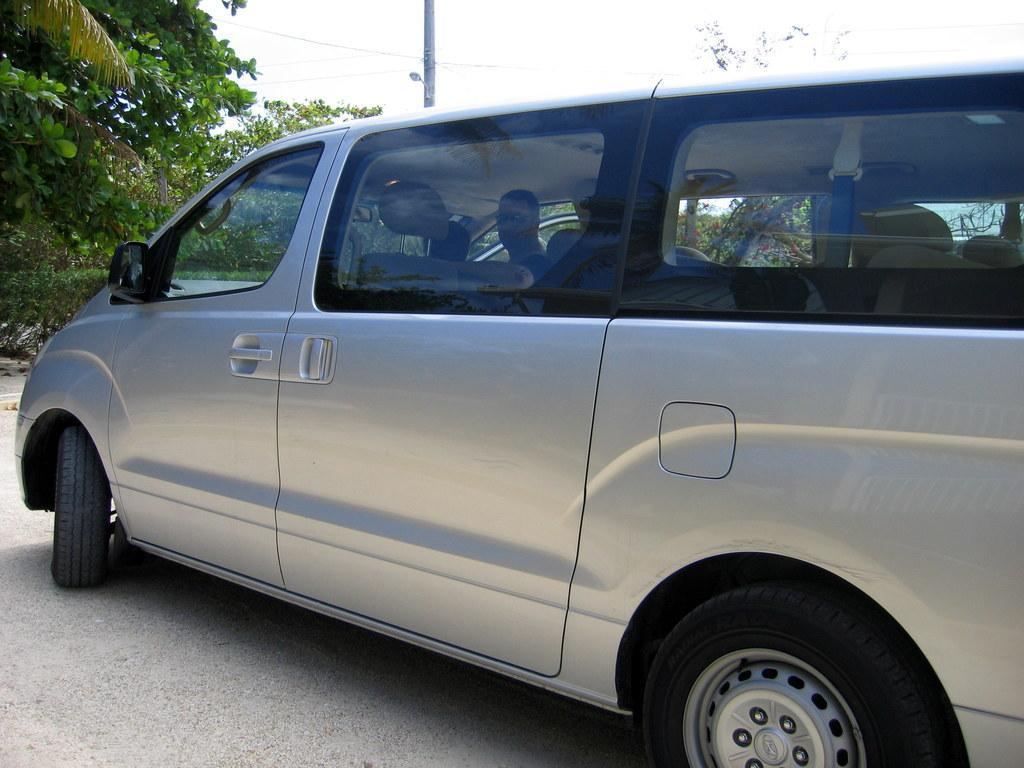Could you give a brief overview of what you see in this image? In this image I can see a vehicle and a person is sitting inside the vehicle and watching the cam. On the left side of the image I can see trees and a pole in the center of the image and at the top of the image I can see the sky.  